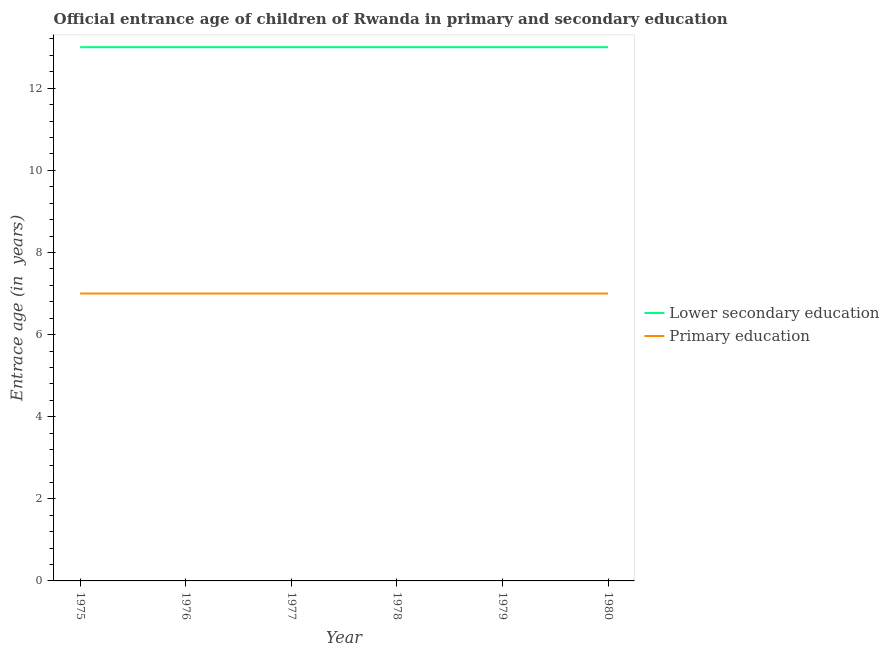Is the number of lines equal to the number of legend labels?
Your answer should be very brief. Yes. What is the entrance age of chiildren in primary education in 1975?
Your answer should be very brief. 7. Across all years, what is the maximum entrance age of children in lower secondary education?
Offer a terse response. 13. Across all years, what is the minimum entrance age of children in lower secondary education?
Provide a succinct answer. 13. In which year was the entrance age of children in lower secondary education maximum?
Offer a terse response. 1975. In which year was the entrance age of chiildren in primary education minimum?
Your answer should be compact. 1975. What is the total entrance age of children in lower secondary education in the graph?
Your answer should be compact. 78. What is the difference between the entrance age of chiildren in primary education in 1977 and that in 1980?
Your answer should be compact. 0. What is the average entrance age of children in lower secondary education per year?
Provide a short and direct response. 13. In the year 1977, what is the difference between the entrance age of children in lower secondary education and entrance age of chiildren in primary education?
Keep it short and to the point. 6. What is the ratio of the entrance age of chiildren in primary education in 1977 to that in 1979?
Give a very brief answer. 1. Is the entrance age of children in lower secondary education in 1976 less than that in 1980?
Give a very brief answer. No. What is the difference between the highest and the lowest entrance age of chiildren in primary education?
Your answer should be very brief. 0. Is the sum of the entrance age of children in lower secondary education in 1977 and 1979 greater than the maximum entrance age of chiildren in primary education across all years?
Keep it short and to the point. Yes. Is the entrance age of children in lower secondary education strictly greater than the entrance age of chiildren in primary education over the years?
Your answer should be compact. Yes. How many lines are there?
Offer a very short reply. 2. What is the difference between two consecutive major ticks on the Y-axis?
Keep it short and to the point. 2. Are the values on the major ticks of Y-axis written in scientific E-notation?
Your answer should be very brief. No. How many legend labels are there?
Offer a terse response. 2. How are the legend labels stacked?
Offer a terse response. Vertical. What is the title of the graph?
Make the answer very short. Official entrance age of children of Rwanda in primary and secondary education. Does "Revenue" appear as one of the legend labels in the graph?
Provide a succinct answer. No. What is the label or title of the X-axis?
Give a very brief answer. Year. What is the label or title of the Y-axis?
Offer a very short reply. Entrace age (in  years). What is the Entrace age (in  years) of Primary education in 1975?
Your response must be concise. 7. What is the Entrace age (in  years) in Primary education in 1977?
Offer a very short reply. 7. What is the Entrace age (in  years) of Lower secondary education in 1978?
Give a very brief answer. 13. What is the Entrace age (in  years) of Primary education in 1978?
Your answer should be compact. 7. What is the Entrace age (in  years) of Lower secondary education in 1979?
Offer a very short reply. 13. What is the Entrace age (in  years) in Primary education in 1979?
Give a very brief answer. 7. Across all years, what is the maximum Entrace age (in  years) of Primary education?
Provide a short and direct response. 7. What is the total Entrace age (in  years) in Primary education in the graph?
Provide a succinct answer. 42. What is the difference between the Entrace age (in  years) in Primary education in 1975 and that in 1976?
Keep it short and to the point. 0. What is the difference between the Entrace age (in  years) in Primary education in 1975 and that in 1977?
Provide a short and direct response. 0. What is the difference between the Entrace age (in  years) of Primary education in 1975 and that in 1978?
Make the answer very short. 0. What is the difference between the Entrace age (in  years) in Lower secondary education in 1975 and that in 1979?
Ensure brevity in your answer.  0. What is the difference between the Entrace age (in  years) in Primary education in 1975 and that in 1979?
Your response must be concise. 0. What is the difference between the Entrace age (in  years) of Lower secondary education in 1975 and that in 1980?
Make the answer very short. 0. What is the difference between the Entrace age (in  years) in Primary education in 1975 and that in 1980?
Make the answer very short. 0. What is the difference between the Entrace age (in  years) of Lower secondary education in 1976 and that in 1977?
Provide a short and direct response. 0. What is the difference between the Entrace age (in  years) of Primary education in 1976 and that in 1978?
Offer a very short reply. 0. What is the difference between the Entrace age (in  years) of Lower secondary education in 1976 and that in 1979?
Your answer should be very brief. 0. What is the difference between the Entrace age (in  years) in Lower secondary education in 1976 and that in 1980?
Give a very brief answer. 0. What is the difference between the Entrace age (in  years) of Primary education in 1977 and that in 1978?
Provide a short and direct response. 0. What is the difference between the Entrace age (in  years) in Lower secondary education in 1977 and that in 1979?
Give a very brief answer. 0. What is the difference between the Entrace age (in  years) of Primary education in 1977 and that in 1979?
Your response must be concise. 0. What is the difference between the Entrace age (in  years) of Lower secondary education in 1978 and that in 1979?
Keep it short and to the point. 0. What is the difference between the Entrace age (in  years) of Lower secondary education in 1978 and that in 1980?
Your answer should be compact. 0. What is the difference between the Entrace age (in  years) of Lower secondary education in 1975 and the Entrace age (in  years) of Primary education in 1976?
Your answer should be compact. 6. What is the difference between the Entrace age (in  years) in Lower secondary education in 1975 and the Entrace age (in  years) in Primary education in 1977?
Your answer should be very brief. 6. What is the difference between the Entrace age (in  years) in Lower secondary education in 1975 and the Entrace age (in  years) in Primary education in 1980?
Give a very brief answer. 6. What is the difference between the Entrace age (in  years) of Lower secondary education in 1976 and the Entrace age (in  years) of Primary education in 1977?
Make the answer very short. 6. What is the difference between the Entrace age (in  years) in Lower secondary education in 1977 and the Entrace age (in  years) in Primary education in 1978?
Make the answer very short. 6. What is the difference between the Entrace age (in  years) of Lower secondary education in 1977 and the Entrace age (in  years) of Primary education in 1979?
Your answer should be very brief. 6. What is the difference between the Entrace age (in  years) in Lower secondary education in 1978 and the Entrace age (in  years) in Primary education in 1979?
Provide a succinct answer. 6. In the year 1977, what is the difference between the Entrace age (in  years) in Lower secondary education and Entrace age (in  years) in Primary education?
Ensure brevity in your answer.  6. In the year 1979, what is the difference between the Entrace age (in  years) of Lower secondary education and Entrace age (in  years) of Primary education?
Your answer should be compact. 6. What is the ratio of the Entrace age (in  years) of Primary education in 1975 to that in 1976?
Your response must be concise. 1. What is the ratio of the Entrace age (in  years) in Lower secondary education in 1975 to that in 1977?
Give a very brief answer. 1. What is the ratio of the Entrace age (in  years) in Primary education in 1975 to that in 1978?
Offer a very short reply. 1. What is the ratio of the Entrace age (in  years) in Primary education in 1975 to that in 1979?
Offer a very short reply. 1. What is the ratio of the Entrace age (in  years) in Primary education in 1975 to that in 1980?
Offer a terse response. 1. What is the ratio of the Entrace age (in  years) in Lower secondary education in 1976 to that in 1977?
Provide a succinct answer. 1. What is the ratio of the Entrace age (in  years) in Primary education in 1976 to that in 1978?
Your answer should be compact. 1. What is the ratio of the Entrace age (in  years) in Lower secondary education in 1976 to that in 1979?
Offer a terse response. 1. What is the ratio of the Entrace age (in  years) of Primary education in 1976 to that in 1979?
Give a very brief answer. 1. What is the ratio of the Entrace age (in  years) in Lower secondary education in 1976 to that in 1980?
Provide a short and direct response. 1. What is the ratio of the Entrace age (in  years) of Lower secondary education in 1977 to that in 1978?
Give a very brief answer. 1. What is the ratio of the Entrace age (in  years) of Primary education in 1977 to that in 1979?
Offer a terse response. 1. What is the ratio of the Entrace age (in  years) of Lower secondary education in 1977 to that in 1980?
Provide a short and direct response. 1. What is the ratio of the Entrace age (in  years) in Primary education in 1977 to that in 1980?
Give a very brief answer. 1. What is the ratio of the Entrace age (in  years) in Primary education in 1978 to that in 1979?
Offer a terse response. 1. What is the ratio of the Entrace age (in  years) of Lower secondary education in 1978 to that in 1980?
Keep it short and to the point. 1. What is the ratio of the Entrace age (in  years) in Primary education in 1979 to that in 1980?
Ensure brevity in your answer.  1. What is the difference between the highest and the lowest Entrace age (in  years) in Lower secondary education?
Your response must be concise. 0. What is the difference between the highest and the lowest Entrace age (in  years) in Primary education?
Provide a succinct answer. 0. 